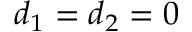Convert formula to latex. <formula><loc_0><loc_0><loc_500><loc_500>d _ { 1 } = d _ { 2 } = 0</formula> 